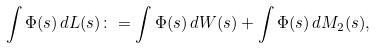<formula> <loc_0><loc_0><loc_500><loc_500>\int \Phi ( s ) \, d L ( s ) \colon = \int \Phi ( s ) \, d W ( s ) + \int \Phi ( s ) \, d M _ { 2 } ( s ) ,</formula> 